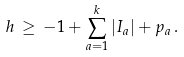Convert formula to latex. <formula><loc_0><loc_0><loc_500><loc_500>h \, \geq \, - 1 + \sum _ { a = 1 } ^ { k } | I _ { a } | + p _ { a } \, .</formula> 